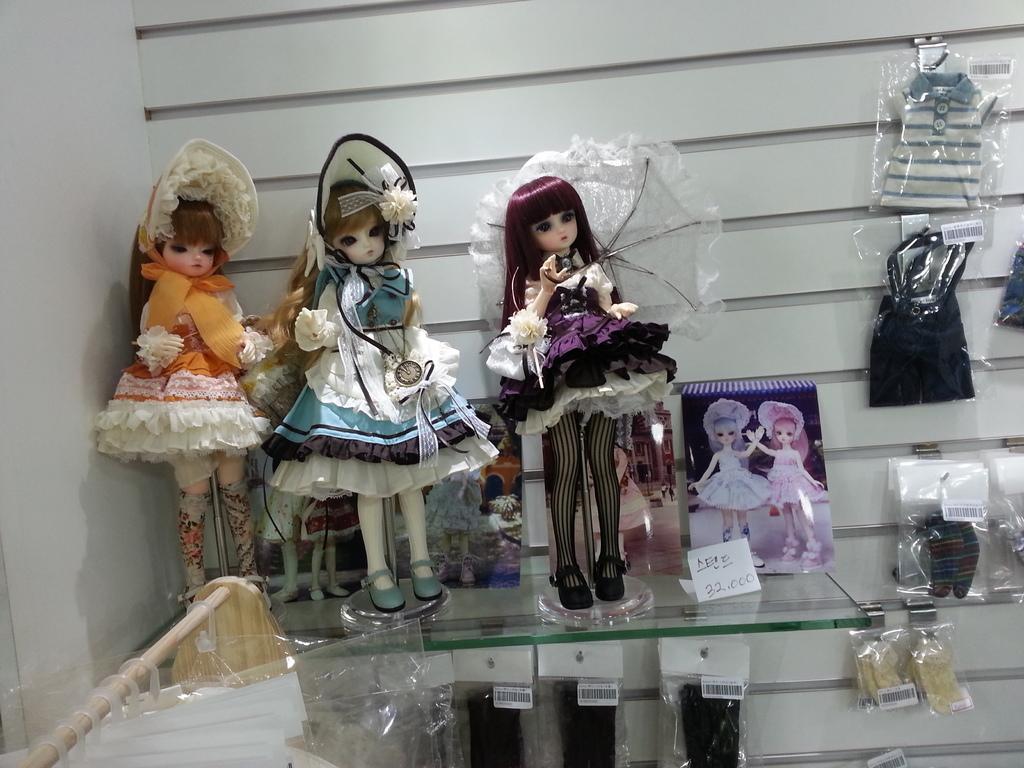Please provide a concise description of this image. In this picture we can see hangers hanged to a wooden pole, socks, stickers, plastic covers, clothes, toys, photos, price card, glass and some objects and in the background we can see walls. 